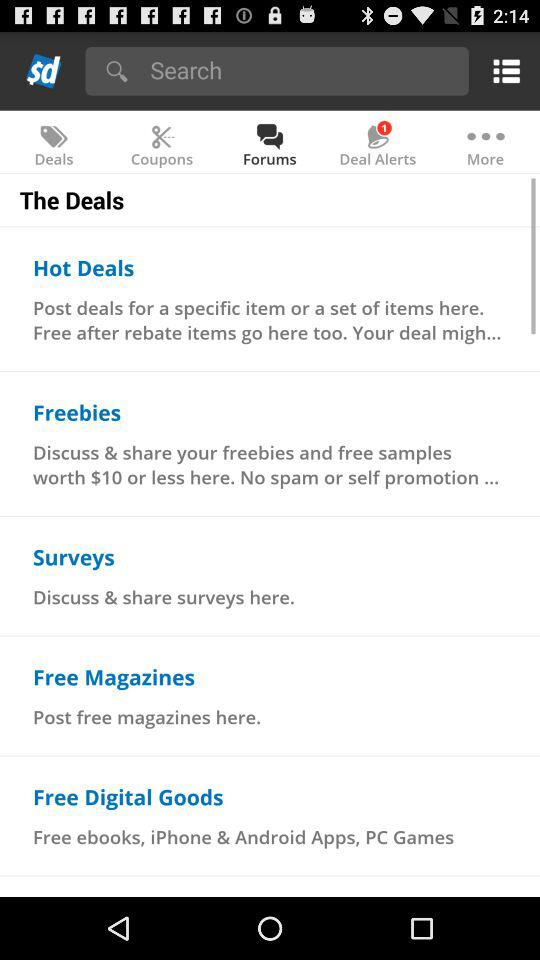What is the count of deal alerts? The count of deal alerts is 1. 